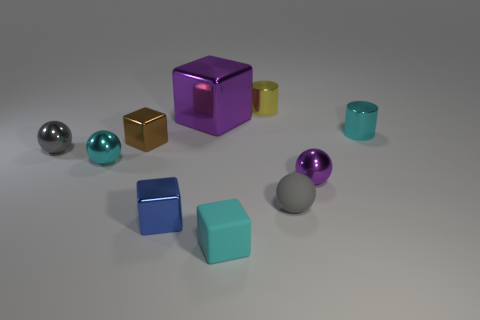Can you describe the objects in the foreground? Certainly! In the foreground, there appear to be two cubes closely positioned to each other. One cube is light blue and has a visible reflection on its surface, indicating it may have a metallic texture. The other is a slightly smaller brown cube with a matte finish. 